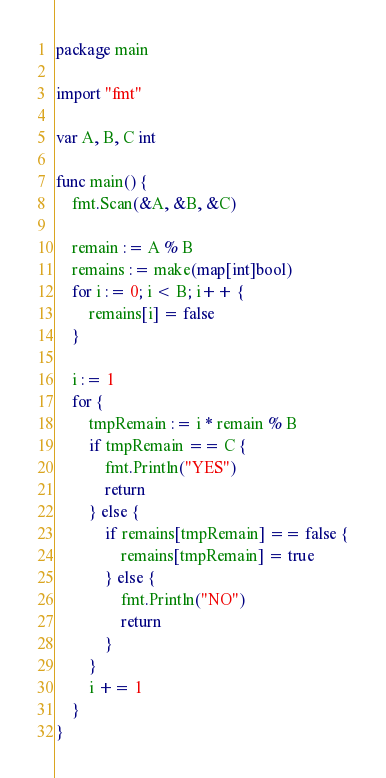Convert code to text. <code><loc_0><loc_0><loc_500><loc_500><_Go_>package main

import "fmt"

var A, B, C int

func main() {
	fmt.Scan(&A, &B, &C)

	remain := A % B
	remains := make(map[int]bool)
	for i := 0; i < B; i++ {
		remains[i] = false
	}

	i := 1
	for {
		tmpRemain := i * remain % B
		if tmpRemain == C {
			fmt.Println("YES")
			return
		} else {
			if remains[tmpRemain] == false {
				remains[tmpRemain] = true
			} else {
				fmt.Println("NO")
				return
			}
		}
		i += 1
	}
}
</code> 